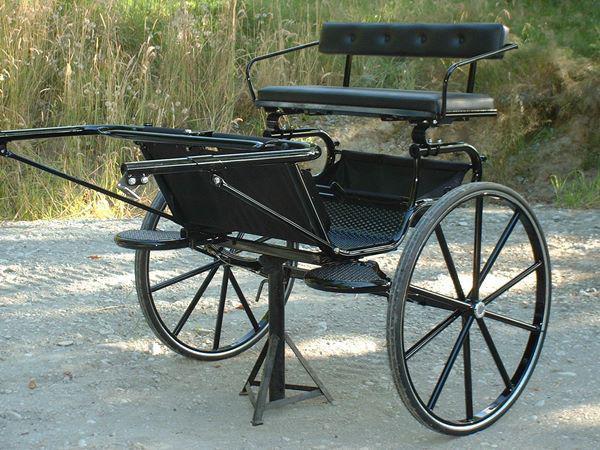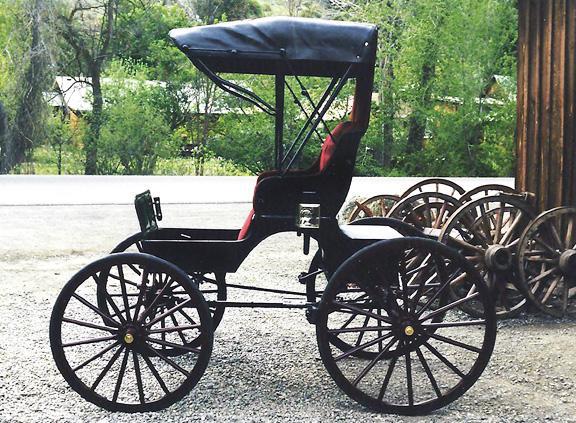The first image is the image on the left, the second image is the image on the right. Given the left and right images, does the statement "The carriage is covered in the image on the right." hold true? Answer yes or no. Yes. 